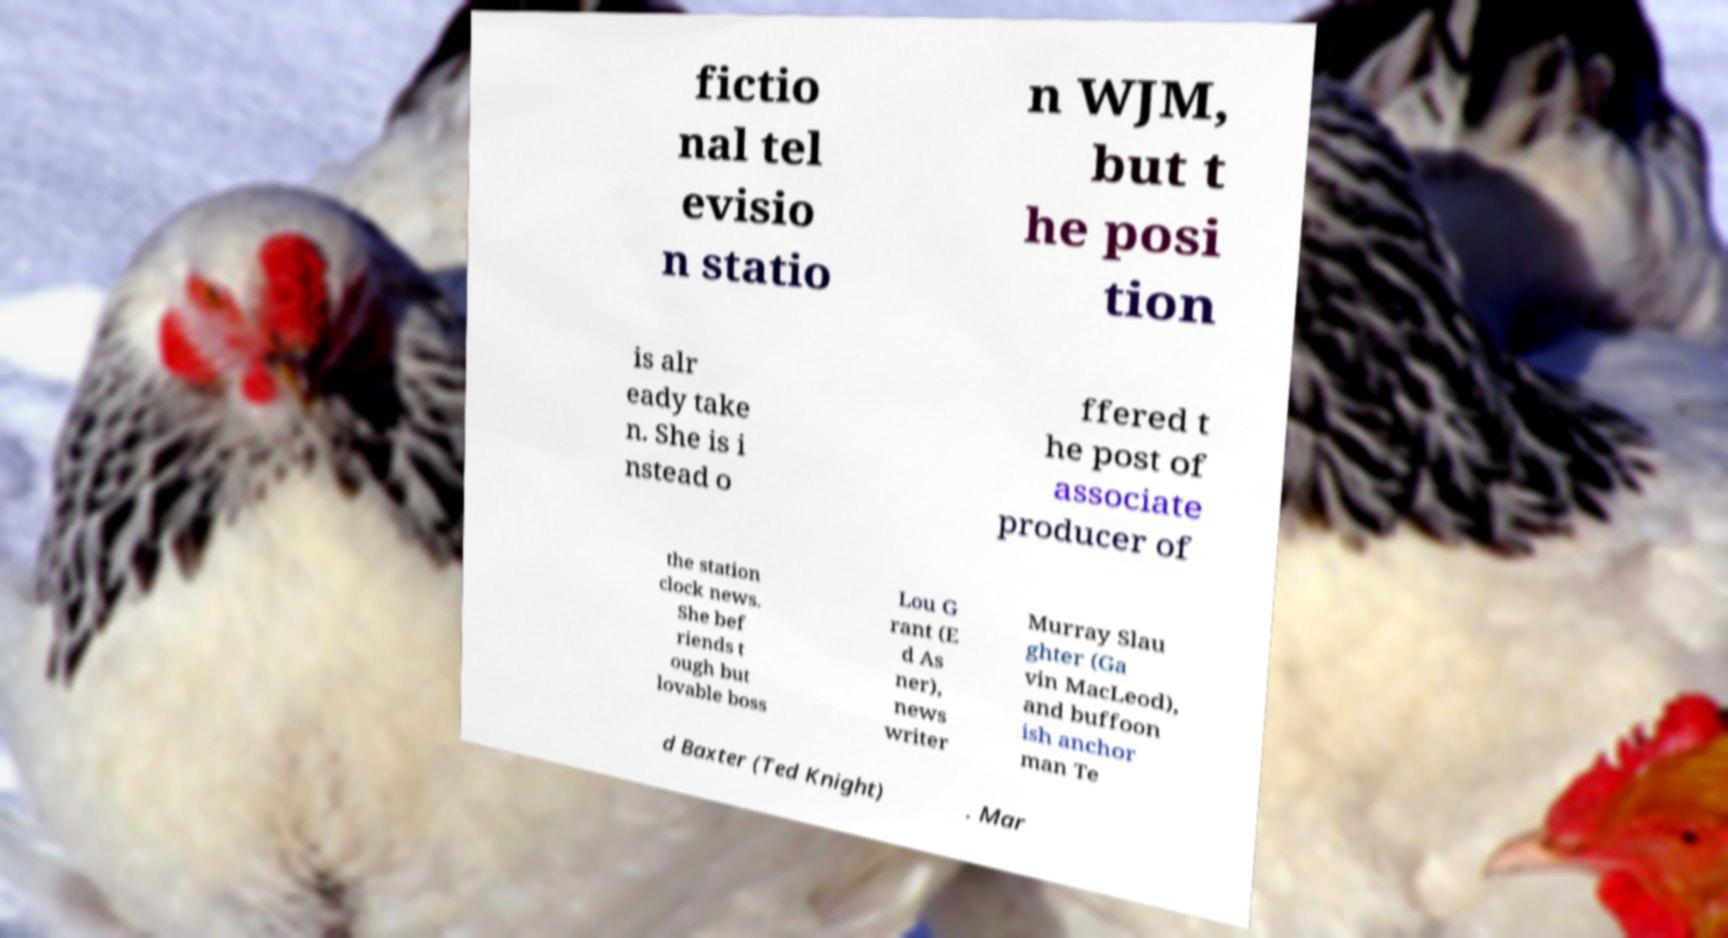Please read and relay the text visible in this image. What does it say? fictio nal tel evisio n statio n WJM, but t he posi tion is alr eady take n. She is i nstead o ffered t he post of associate producer of the station clock news. She bef riends t ough but lovable boss Lou G rant (E d As ner), news writer Murray Slau ghter (Ga vin MacLeod), and buffoon ish anchor man Te d Baxter (Ted Knight) . Mar 